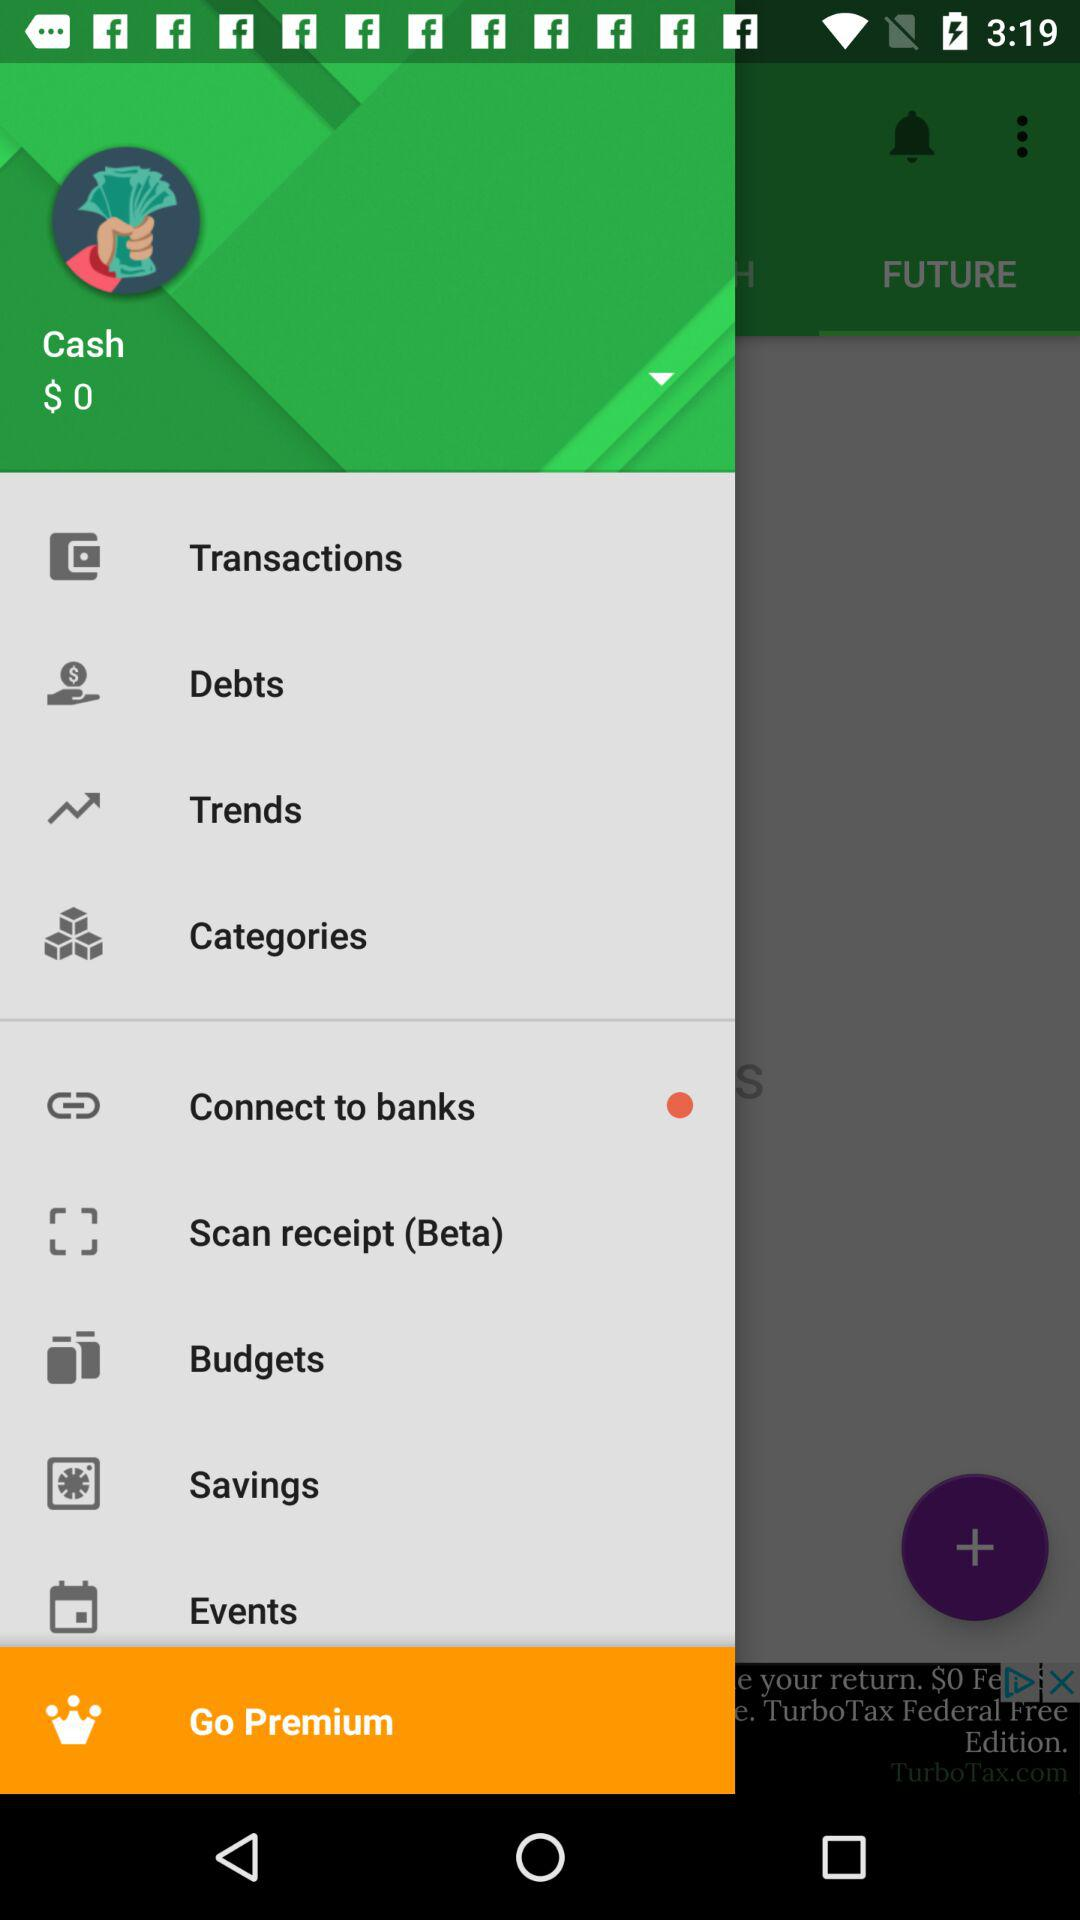How many items have a red circle?
Answer the question using a single word or phrase. 1 